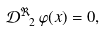<formula> <loc_0><loc_0><loc_500><loc_500>\mathcal { D } _ { \ 2 } ^ { \Re } \, \varphi ( x ) = 0 ,</formula> 